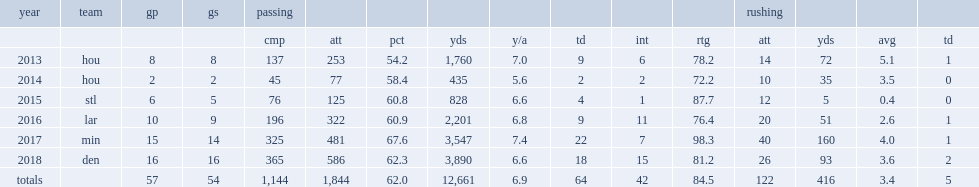How many yards did keenum make in the 2015 season? 828.0. Could you parse the entire table? {'header': ['year', 'team', 'gp', 'gs', 'passing', '', '', '', '', '', '', '', 'rushing', '', '', ''], 'rows': [['', '', '', '', 'cmp', 'att', 'pct', 'yds', 'y/a', 'td', 'int', 'rtg', 'att', 'yds', 'avg', 'td'], ['2013', 'hou', '8', '8', '137', '253', '54.2', '1,760', '7.0', '9', '6', '78.2', '14', '72', '5.1', '1'], ['2014', 'hou', '2', '2', '45', '77', '58.4', '435', '5.6', '2', '2', '72.2', '10', '35', '3.5', '0'], ['2015', 'stl', '6', '5', '76', '125', '60.8', '828', '6.6', '4', '1', '87.7', '12', '5', '0.4', '0'], ['2016', 'lar', '10', '9', '196', '322', '60.9', '2,201', '6.8', '9', '11', '76.4', '20', '51', '2.6', '1'], ['2017', 'min', '15', '14', '325', '481', '67.6', '3,547', '7.4', '22', '7', '98.3', '40', '160', '4.0', '1'], ['2018', 'den', '16', '16', '365', '586', '62.3', '3,890', '6.6', '18', '15', '81.2', '26', '93', '3.6', '2'], ['totals', '', '57', '54', '1,144', '1,844', '62.0', '12,661', '6.9', '64', '42', '84.5', '122', '416', '3.4', '5']]} 